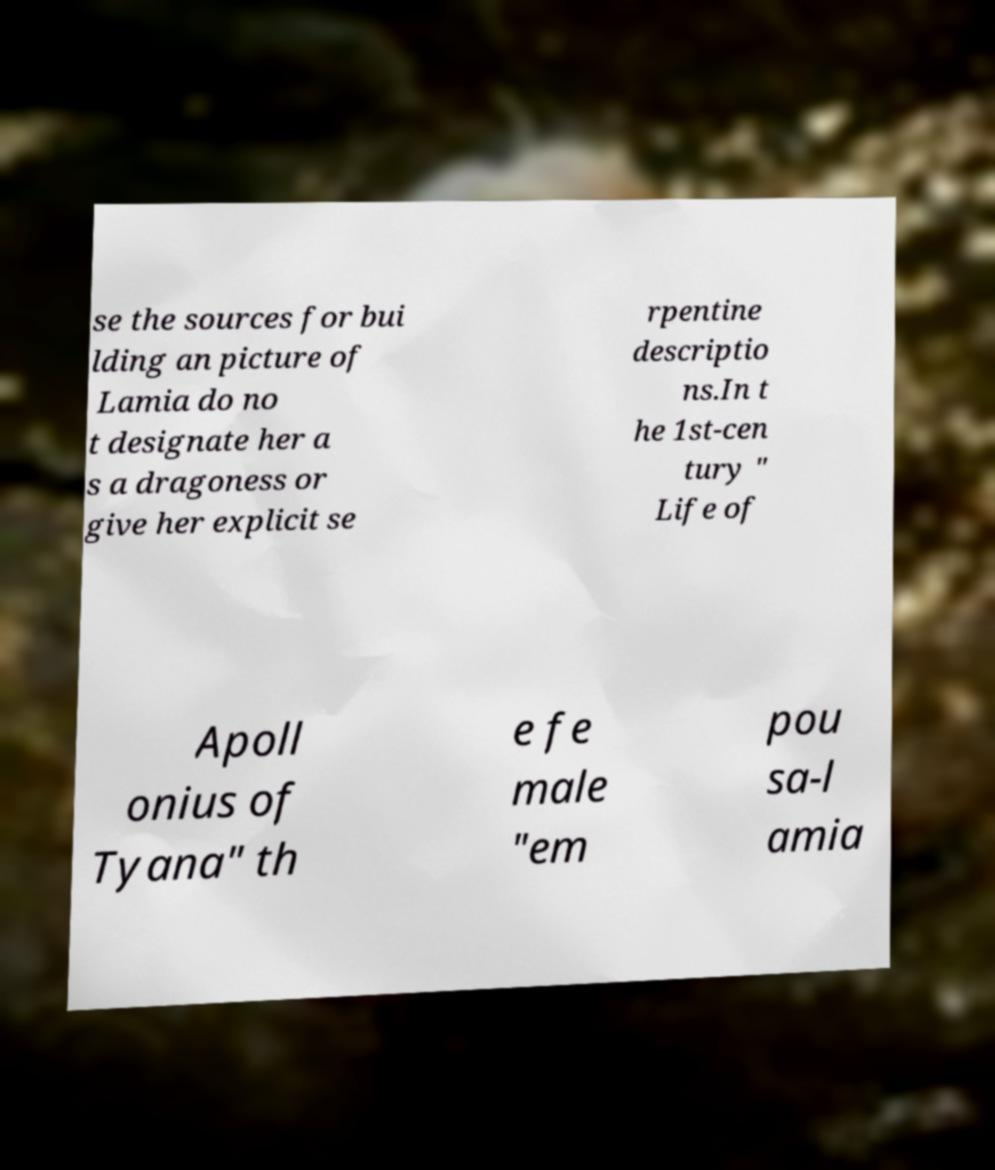I need the written content from this picture converted into text. Can you do that? se the sources for bui lding an picture of Lamia do no t designate her a s a dragoness or give her explicit se rpentine descriptio ns.In t he 1st-cen tury " Life of Apoll onius of Tyana" th e fe male "em pou sa-l amia 